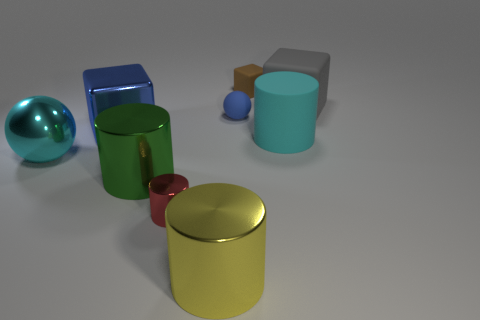Subtract all gray blocks. Subtract all blue balls. How many blocks are left? 2 Subtract all cylinders. How many objects are left? 5 Add 4 rubber balls. How many rubber balls are left? 5 Add 2 yellow cylinders. How many yellow cylinders exist? 3 Subtract 0 blue cylinders. How many objects are left? 9 Subtract all brown shiny objects. Subtract all red metallic cylinders. How many objects are left? 8 